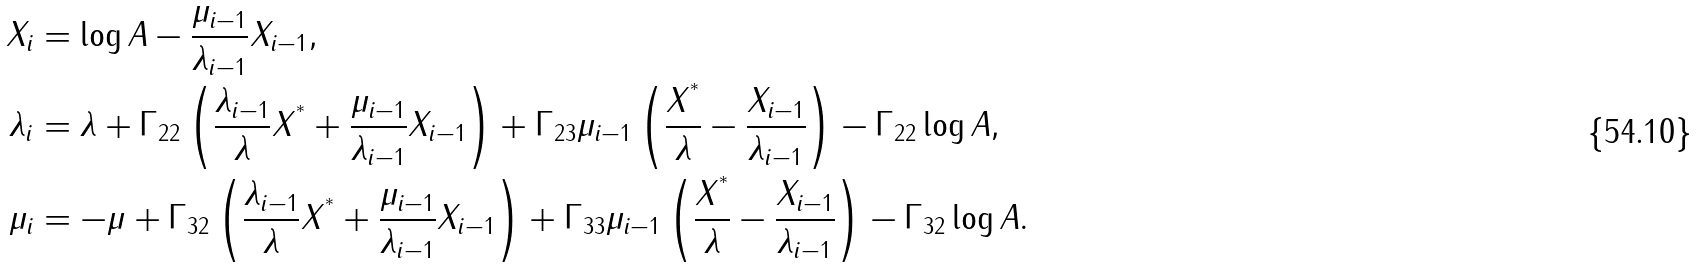<formula> <loc_0><loc_0><loc_500><loc_500>X _ { i } & = \log A - \frac { \mu _ { i - 1 } } { \lambda _ { i - 1 } } X _ { i - 1 } , \\ \lambda _ { i } & = \lambda + \Gamma _ { 2 2 } \left ( \frac { \lambda _ { i - 1 } } { \lambda } X ^ { ^ { * } } + \frac { \mu _ { i - 1 } } { \lambda _ { i - 1 } } X _ { i - 1 } \right ) + \Gamma _ { 2 3 } \mu _ { i - 1 } \left ( \frac { X ^ { ^ { * } } } { \lambda } - \frac { X _ { i - 1 } } { \lambda _ { i - 1 } } \right ) - \Gamma _ { 2 2 } \log A , \\ \mu _ { i } & = - \mu + \Gamma _ { 3 2 } \left ( \frac { \lambda _ { i - 1 } } { \lambda } X ^ { ^ { * } } + \frac { \mu _ { i - 1 } } { \lambda _ { i - 1 } } X _ { i - 1 } \right ) + \Gamma _ { 3 3 } \mu _ { i - 1 } \left ( \frac { X ^ { ^ { * } } } { \lambda } - \frac { X _ { i - 1 } } { \lambda _ { i - 1 } } \right ) - \Gamma _ { 3 2 } \log A .</formula> 